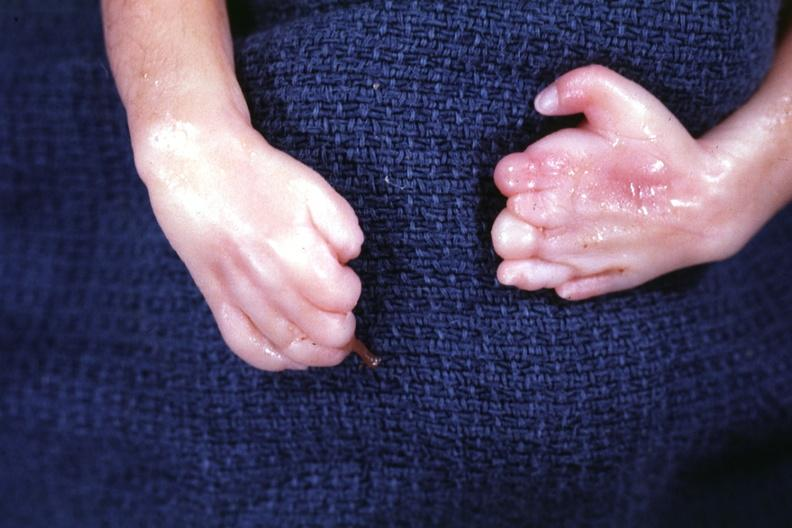s conjoined twins present?
Answer the question using a single word or phrase. Yes 